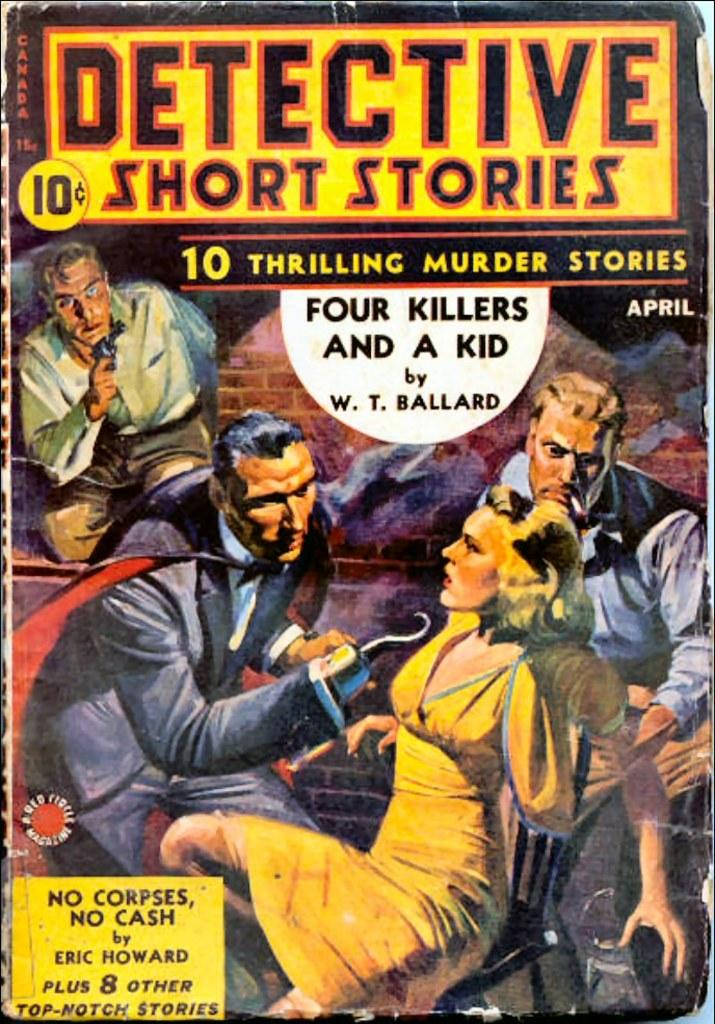<image>
Describe the image concisely. Book titled "Detective Short Stories" showing a man questioning a woman with a hook. 